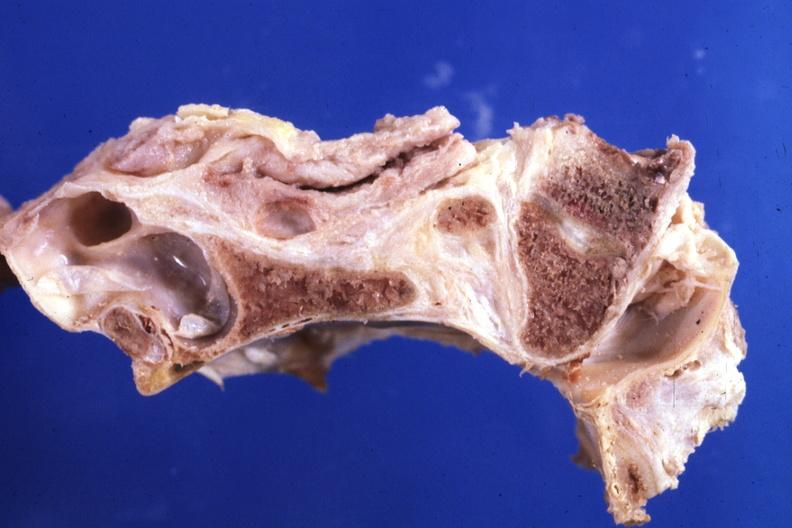s bone, calvarium present?
Answer the question using a single word or phrase. Yes 